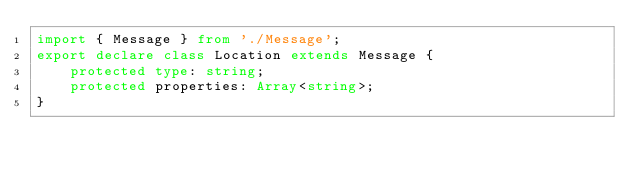Convert code to text. <code><loc_0><loc_0><loc_500><loc_500><_TypeScript_>import { Message } from './Message';
export declare class Location extends Message {
    protected type: string;
    protected properties: Array<string>;
}
</code> 